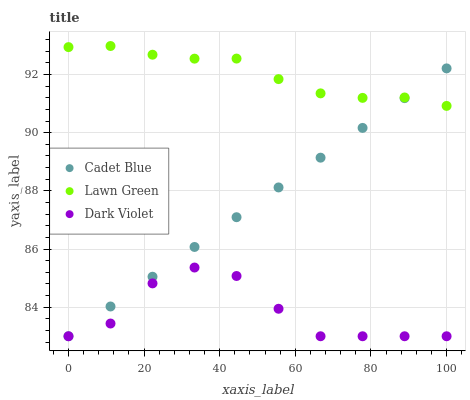Does Dark Violet have the minimum area under the curve?
Answer yes or no. Yes. Does Lawn Green have the maximum area under the curve?
Answer yes or no. Yes. Does Cadet Blue have the minimum area under the curve?
Answer yes or no. No. Does Cadet Blue have the maximum area under the curve?
Answer yes or no. No. Is Cadet Blue the smoothest?
Answer yes or no. Yes. Is Dark Violet the roughest?
Answer yes or no. Yes. Is Dark Violet the smoothest?
Answer yes or no. No. Is Cadet Blue the roughest?
Answer yes or no. No. Does Cadet Blue have the lowest value?
Answer yes or no. Yes. Does Lawn Green have the highest value?
Answer yes or no. Yes. Does Cadet Blue have the highest value?
Answer yes or no. No. Is Dark Violet less than Lawn Green?
Answer yes or no. Yes. Is Lawn Green greater than Dark Violet?
Answer yes or no. Yes. Does Dark Violet intersect Cadet Blue?
Answer yes or no. Yes. Is Dark Violet less than Cadet Blue?
Answer yes or no. No. Is Dark Violet greater than Cadet Blue?
Answer yes or no. No. Does Dark Violet intersect Lawn Green?
Answer yes or no. No. 